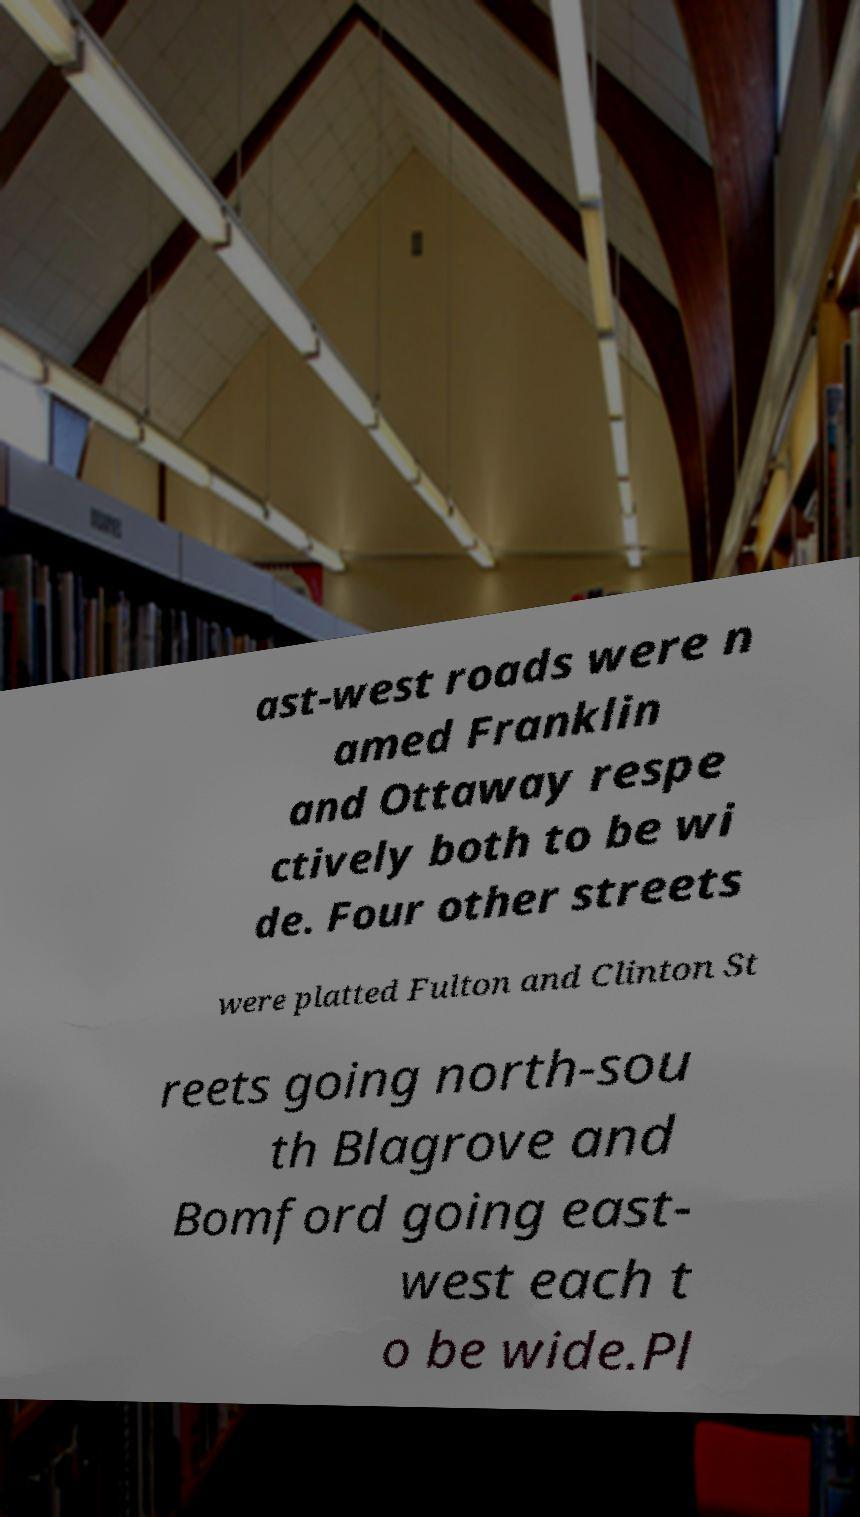There's text embedded in this image that I need extracted. Can you transcribe it verbatim? ast-west roads were n amed Franklin and Ottaway respe ctively both to be wi de. Four other streets were platted Fulton and Clinton St reets going north-sou th Blagrove and Bomford going east- west each t o be wide.Pl 